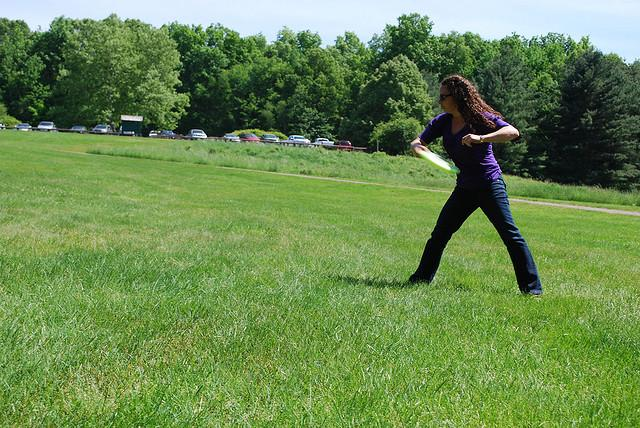What color are her glasses? Please explain your reasoning. black. The glasses are too dark to be white, but lack any other color. 